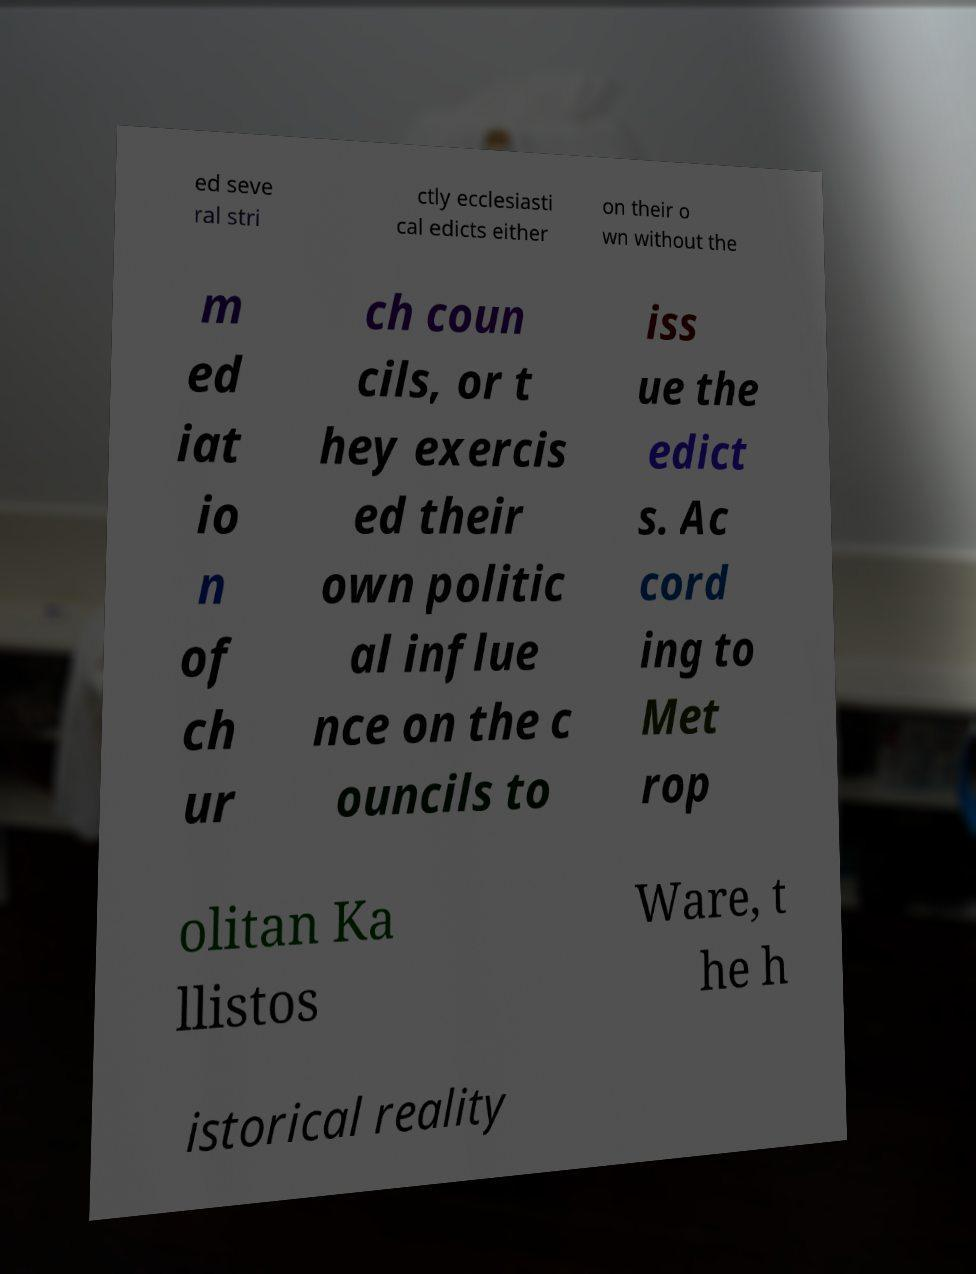What messages or text are displayed in this image? I need them in a readable, typed format. ed seve ral stri ctly ecclesiasti cal edicts either on their o wn without the m ed iat io n of ch ur ch coun cils, or t hey exercis ed their own politic al influe nce on the c ouncils to iss ue the edict s. Ac cord ing to Met rop olitan Ka llistos Ware, t he h istorical reality 